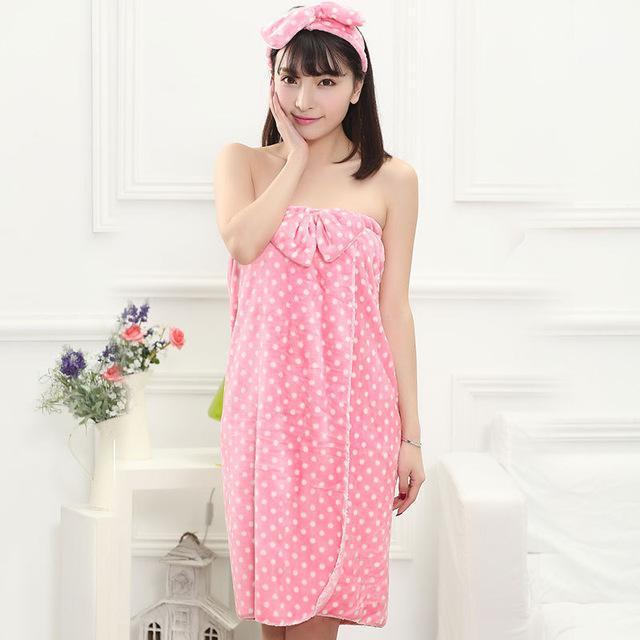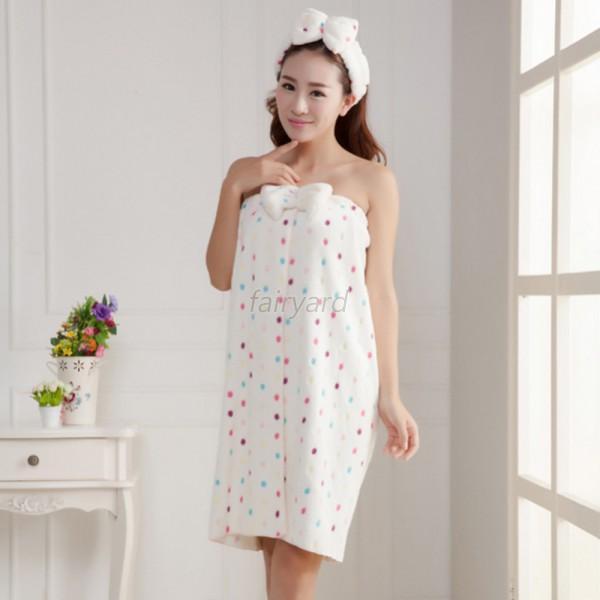The first image is the image on the left, the second image is the image on the right. Assess this claim about the two images: "At least one of the women has her hand to her face.". Correct or not? Answer yes or no. Yes. The first image is the image on the left, the second image is the image on the right. Evaluate the accuracy of this statement regarding the images: "One woman's towel is pink with white polka dots.". Is it true? Answer yes or no. Yes. 